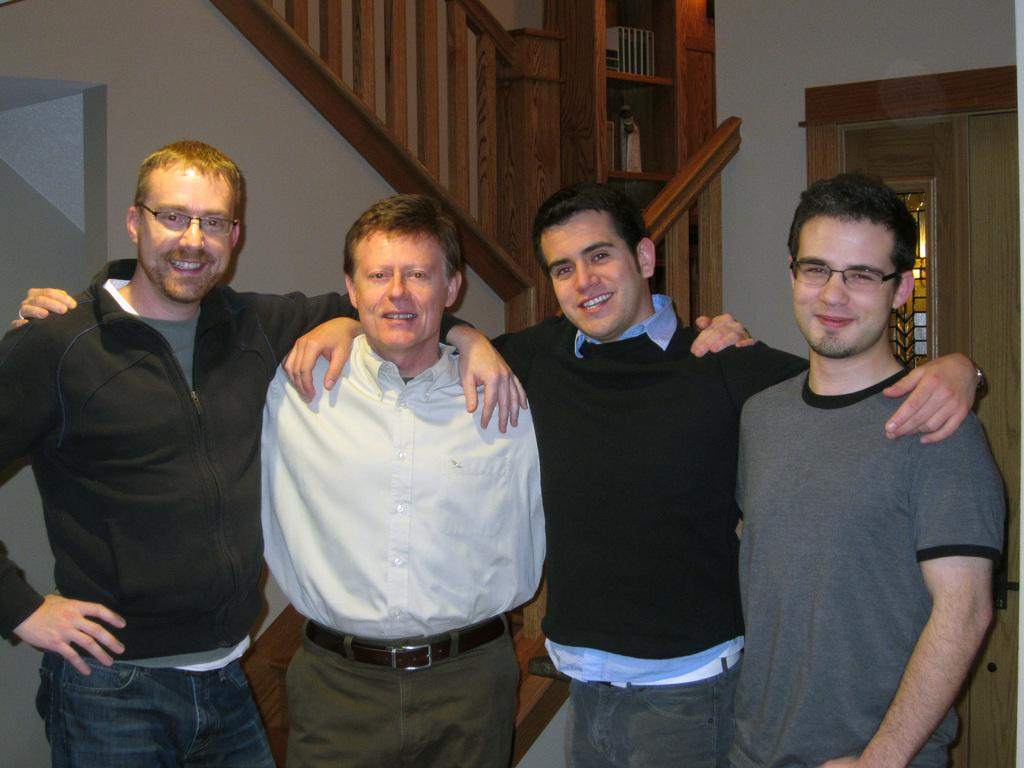What is the main subject of the image? The main subject of the image is a group of men. What are the men doing in the image? The men are standing and smiling, and they are posing for the camera. What can be seen in the background of the image? There is a wooden railing and a door in the background of the image. How quiet is the blood dripping from the spade in the image? There is no blood or spade present in the image, so this question cannot be answered. 